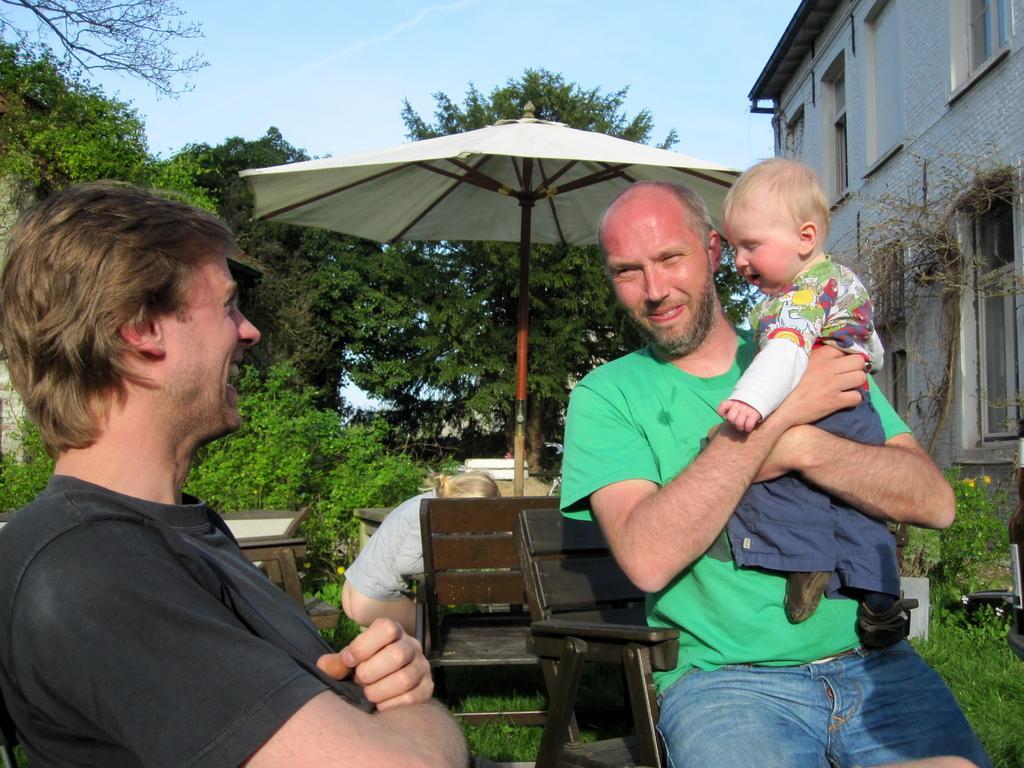Describe this image in one or two sentences. In this picture I can see couple of men seated on the chairs and I can see a man holding a baby in his hands and I can see an umbrella and few chairs and tables, I can see another human in the back and I can see trees and a building on the right side and I can see a blue cloudy sky and few plants. 